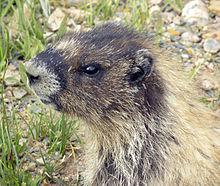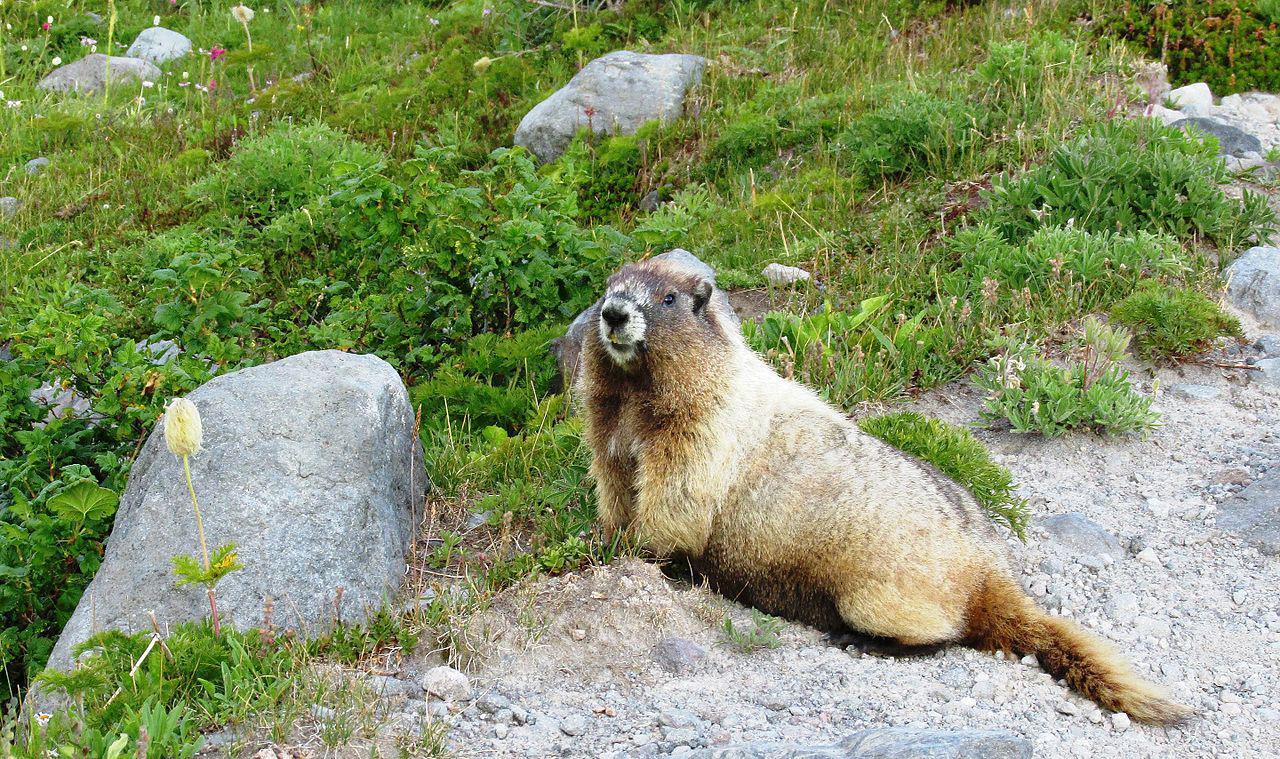The first image is the image on the left, the second image is the image on the right. Analyze the images presented: Is the assertion "There is 1 or more woodchucks facing right." valid? Answer yes or no. No. The first image is the image on the left, the second image is the image on the right. Analyze the images presented: Is the assertion "In one of the photos, the marmot's nose is near a blossom." valid? Answer yes or no. No. 